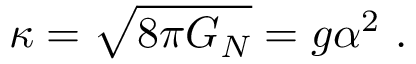<formula> <loc_0><loc_0><loc_500><loc_500>\kappa = \sqrt { 8 \pi G _ { N } } = g \alpha ^ { 2 } \ .</formula> 